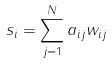Convert formula to latex. <formula><loc_0><loc_0><loc_500><loc_500>s _ { i } = \sum _ { j = 1 } ^ { N } a _ { i j } w _ { i j }</formula> 